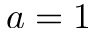<formula> <loc_0><loc_0><loc_500><loc_500>a = 1</formula> 